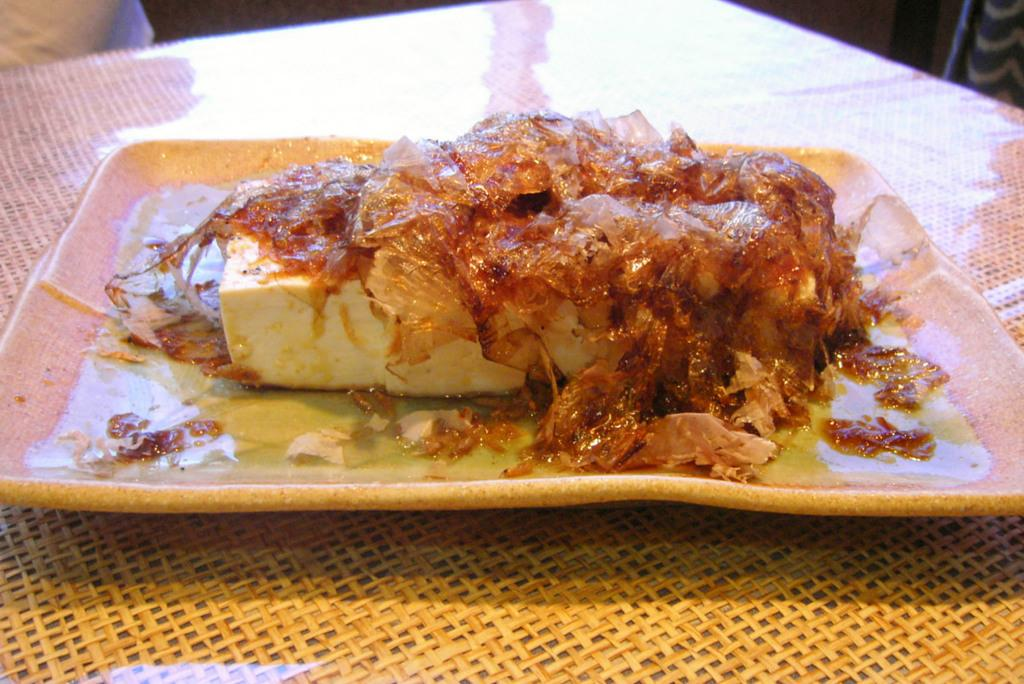What is present in the image that people typically consume? There is food in the image. What is the food placed on in the image? There is a plate in the image. Where is the plate located in the image? The plate is placed on a table. What month is it in the image? The month cannot be determined from the image, as it does not contain any information about the time or date. 